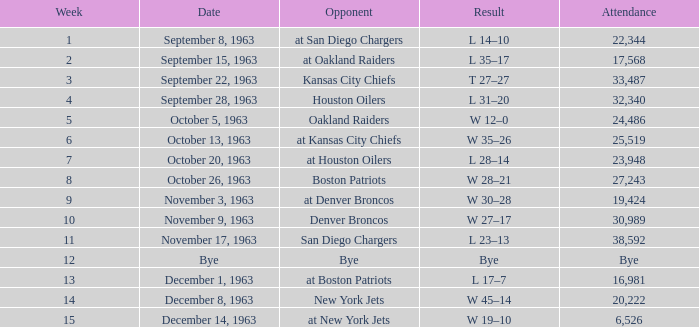Which Opponent has a Result of w 19–10? At new york jets. 